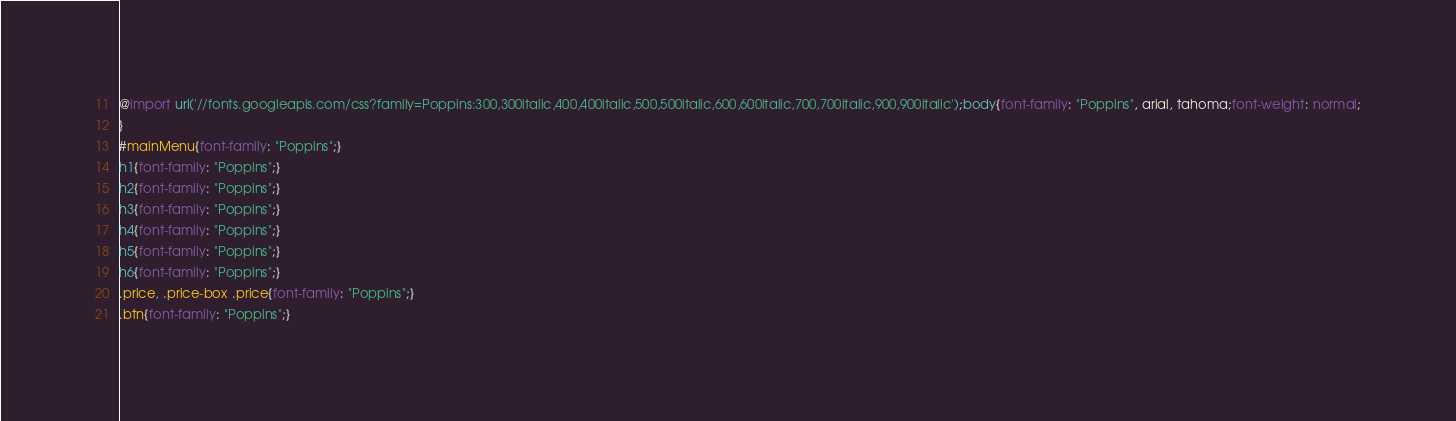<code> <loc_0><loc_0><loc_500><loc_500><_CSS_>@import url('//fonts.googleapis.com/css?family=Poppins:300,300italic,400,400italic,500,500italic,600,600italic,700,700italic,900,900italic');body{font-family: "Poppins", arial, tahoma;font-weight: normal;
}
#mainMenu{font-family: "Poppins";}
h1{font-family: "Poppins";}
h2{font-family: "Poppins";}
h3{font-family: "Poppins";}
h4{font-family: "Poppins";}
h5{font-family: "Poppins";}
h6{font-family: "Poppins";}
.price, .price-box .price{font-family: "Poppins";}
.btn{font-family: "Poppins";}
</code> 